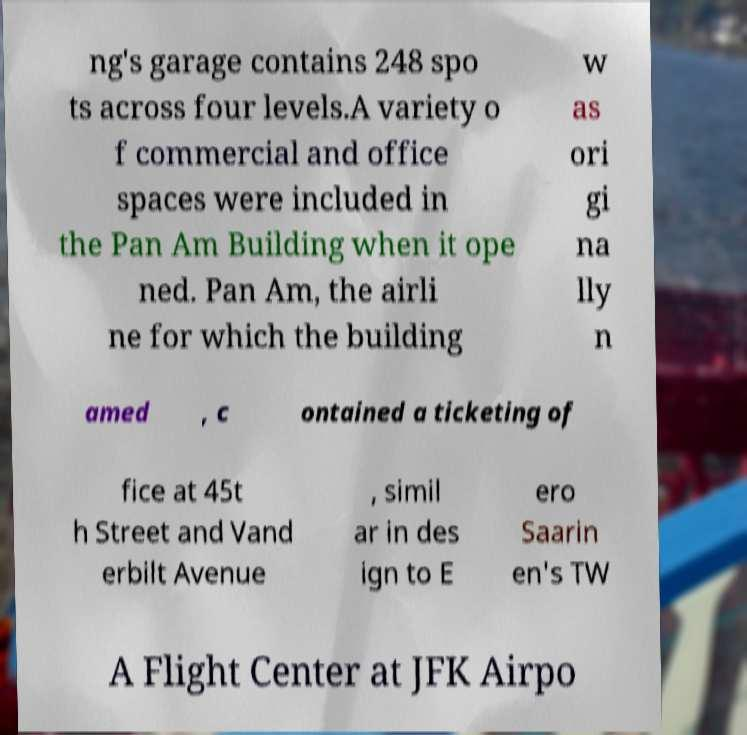Can you read and provide the text displayed in the image?This photo seems to have some interesting text. Can you extract and type it out for me? ng's garage contains 248 spo ts across four levels.A variety o f commercial and office spaces were included in the Pan Am Building when it ope ned. Pan Am, the airli ne for which the building w as ori gi na lly n amed , c ontained a ticketing of fice at 45t h Street and Vand erbilt Avenue , simil ar in des ign to E ero Saarin en's TW A Flight Center at JFK Airpo 